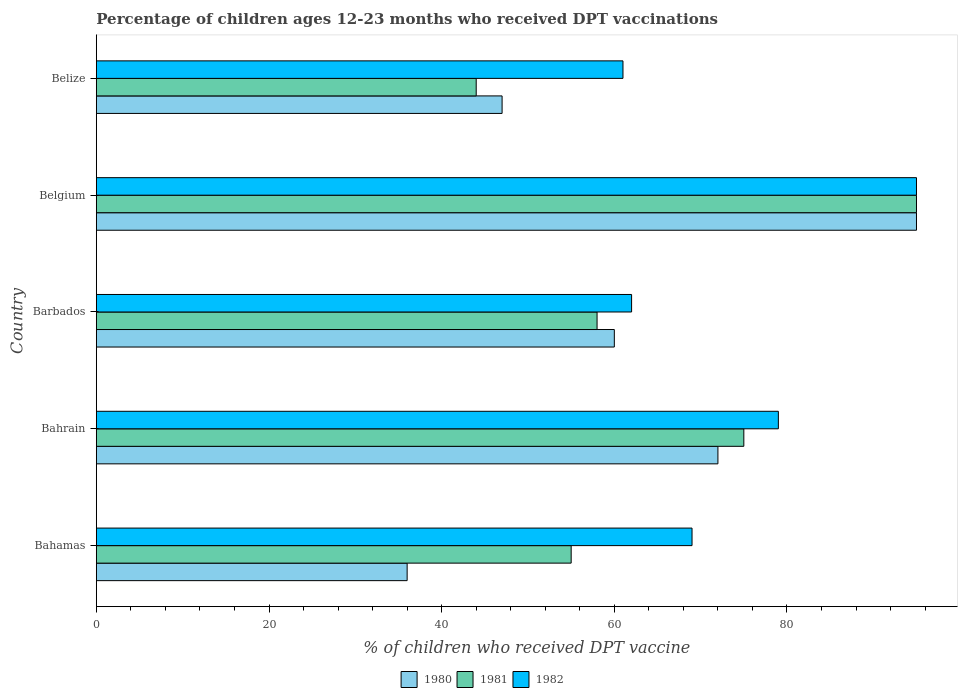How many groups of bars are there?
Offer a very short reply. 5. Are the number of bars on each tick of the Y-axis equal?
Your response must be concise. Yes. How many bars are there on the 1st tick from the bottom?
Ensure brevity in your answer.  3. What is the percentage of children who received DPT vaccination in 1981 in Belize?
Offer a very short reply. 44. Across all countries, what is the maximum percentage of children who received DPT vaccination in 1980?
Provide a succinct answer. 95. In which country was the percentage of children who received DPT vaccination in 1981 minimum?
Your answer should be very brief. Belize. What is the total percentage of children who received DPT vaccination in 1982 in the graph?
Ensure brevity in your answer.  366. What is the difference between the percentage of children who received DPT vaccination in 1982 in Barbados and that in Belgium?
Offer a terse response. -33. What is the difference between the percentage of children who received DPT vaccination in 1980 in Bahrain and the percentage of children who received DPT vaccination in 1981 in Belgium?
Provide a succinct answer. -23. What is the average percentage of children who received DPT vaccination in 1981 per country?
Ensure brevity in your answer.  65.4. What is the difference between the percentage of children who received DPT vaccination in 1980 and percentage of children who received DPT vaccination in 1981 in Bahamas?
Make the answer very short. -19. What is the ratio of the percentage of children who received DPT vaccination in 1981 in Bahrain to that in Belize?
Make the answer very short. 1.7. What is the difference between the highest and the second highest percentage of children who received DPT vaccination in 1981?
Ensure brevity in your answer.  20. What is the difference between the highest and the lowest percentage of children who received DPT vaccination in 1982?
Provide a short and direct response. 34. In how many countries, is the percentage of children who received DPT vaccination in 1980 greater than the average percentage of children who received DPT vaccination in 1980 taken over all countries?
Provide a short and direct response. 2. Is the sum of the percentage of children who received DPT vaccination in 1981 in Bahamas and Belize greater than the maximum percentage of children who received DPT vaccination in 1980 across all countries?
Offer a terse response. Yes. Is it the case that in every country, the sum of the percentage of children who received DPT vaccination in 1980 and percentage of children who received DPT vaccination in 1982 is greater than the percentage of children who received DPT vaccination in 1981?
Keep it short and to the point. Yes. How many bars are there?
Your answer should be compact. 15. Are the values on the major ticks of X-axis written in scientific E-notation?
Provide a succinct answer. No. Does the graph contain grids?
Provide a short and direct response. No. What is the title of the graph?
Ensure brevity in your answer.  Percentage of children ages 12-23 months who received DPT vaccinations. What is the label or title of the X-axis?
Offer a terse response. % of children who received DPT vaccine. What is the label or title of the Y-axis?
Give a very brief answer. Country. What is the % of children who received DPT vaccine of 1980 in Bahamas?
Keep it short and to the point. 36. What is the % of children who received DPT vaccine of 1980 in Bahrain?
Offer a very short reply. 72. What is the % of children who received DPT vaccine of 1981 in Bahrain?
Provide a short and direct response. 75. What is the % of children who received DPT vaccine in 1982 in Bahrain?
Provide a succinct answer. 79. What is the % of children who received DPT vaccine in 1981 in Barbados?
Your answer should be compact. 58. What is the % of children who received DPT vaccine of 1980 in Belgium?
Keep it short and to the point. 95. What is the % of children who received DPT vaccine of 1981 in Belgium?
Give a very brief answer. 95. What is the % of children who received DPT vaccine in 1982 in Belgium?
Ensure brevity in your answer.  95. What is the % of children who received DPT vaccine of 1980 in Belize?
Provide a succinct answer. 47. Across all countries, what is the maximum % of children who received DPT vaccine of 1980?
Make the answer very short. 95. Across all countries, what is the maximum % of children who received DPT vaccine in 1982?
Keep it short and to the point. 95. Across all countries, what is the minimum % of children who received DPT vaccine of 1980?
Your answer should be compact. 36. What is the total % of children who received DPT vaccine of 1980 in the graph?
Keep it short and to the point. 310. What is the total % of children who received DPT vaccine of 1981 in the graph?
Provide a succinct answer. 327. What is the total % of children who received DPT vaccine in 1982 in the graph?
Offer a terse response. 366. What is the difference between the % of children who received DPT vaccine of 1980 in Bahamas and that in Bahrain?
Make the answer very short. -36. What is the difference between the % of children who received DPT vaccine of 1982 in Bahamas and that in Barbados?
Your answer should be very brief. 7. What is the difference between the % of children who received DPT vaccine in 1980 in Bahamas and that in Belgium?
Your answer should be very brief. -59. What is the difference between the % of children who received DPT vaccine of 1981 in Bahamas and that in Belgium?
Make the answer very short. -40. What is the difference between the % of children who received DPT vaccine of 1982 in Bahamas and that in Belgium?
Keep it short and to the point. -26. What is the difference between the % of children who received DPT vaccine in 1980 in Bahamas and that in Belize?
Your response must be concise. -11. What is the difference between the % of children who received DPT vaccine in 1980 in Bahrain and that in Barbados?
Offer a terse response. 12. What is the difference between the % of children who received DPT vaccine of 1981 in Bahrain and that in Barbados?
Offer a terse response. 17. What is the difference between the % of children who received DPT vaccine of 1980 in Bahrain and that in Belgium?
Provide a short and direct response. -23. What is the difference between the % of children who received DPT vaccine of 1981 in Bahrain and that in Belize?
Your answer should be very brief. 31. What is the difference between the % of children who received DPT vaccine of 1982 in Bahrain and that in Belize?
Ensure brevity in your answer.  18. What is the difference between the % of children who received DPT vaccine of 1980 in Barbados and that in Belgium?
Your answer should be compact. -35. What is the difference between the % of children who received DPT vaccine in 1981 in Barbados and that in Belgium?
Your response must be concise. -37. What is the difference between the % of children who received DPT vaccine of 1982 in Barbados and that in Belgium?
Your answer should be compact. -33. What is the difference between the % of children who received DPT vaccine of 1980 in Barbados and that in Belize?
Offer a very short reply. 13. What is the difference between the % of children who received DPT vaccine in 1981 in Barbados and that in Belize?
Give a very brief answer. 14. What is the difference between the % of children who received DPT vaccine in 1982 in Barbados and that in Belize?
Provide a succinct answer. 1. What is the difference between the % of children who received DPT vaccine of 1982 in Belgium and that in Belize?
Your answer should be very brief. 34. What is the difference between the % of children who received DPT vaccine in 1980 in Bahamas and the % of children who received DPT vaccine in 1981 in Bahrain?
Your response must be concise. -39. What is the difference between the % of children who received DPT vaccine of 1980 in Bahamas and the % of children who received DPT vaccine of 1982 in Bahrain?
Ensure brevity in your answer.  -43. What is the difference between the % of children who received DPT vaccine of 1981 in Bahamas and the % of children who received DPT vaccine of 1982 in Bahrain?
Offer a very short reply. -24. What is the difference between the % of children who received DPT vaccine in 1980 in Bahamas and the % of children who received DPT vaccine in 1981 in Barbados?
Offer a terse response. -22. What is the difference between the % of children who received DPT vaccine of 1980 in Bahamas and the % of children who received DPT vaccine of 1982 in Barbados?
Offer a very short reply. -26. What is the difference between the % of children who received DPT vaccine of 1980 in Bahamas and the % of children who received DPT vaccine of 1981 in Belgium?
Provide a succinct answer. -59. What is the difference between the % of children who received DPT vaccine of 1980 in Bahamas and the % of children who received DPT vaccine of 1982 in Belgium?
Make the answer very short. -59. What is the difference between the % of children who received DPT vaccine of 1981 in Bahamas and the % of children who received DPT vaccine of 1982 in Belgium?
Give a very brief answer. -40. What is the difference between the % of children who received DPT vaccine of 1980 in Bahamas and the % of children who received DPT vaccine of 1982 in Belize?
Keep it short and to the point. -25. What is the difference between the % of children who received DPT vaccine in 1980 in Bahrain and the % of children who received DPT vaccine in 1981 in Barbados?
Your response must be concise. 14. What is the difference between the % of children who received DPT vaccine in 1980 in Bahrain and the % of children who received DPT vaccine in 1982 in Barbados?
Your answer should be compact. 10. What is the difference between the % of children who received DPT vaccine in 1980 in Bahrain and the % of children who received DPT vaccine in 1981 in Belgium?
Offer a very short reply. -23. What is the difference between the % of children who received DPT vaccine of 1980 in Bahrain and the % of children who received DPT vaccine of 1981 in Belize?
Provide a succinct answer. 28. What is the difference between the % of children who received DPT vaccine of 1980 in Barbados and the % of children who received DPT vaccine of 1981 in Belgium?
Offer a very short reply. -35. What is the difference between the % of children who received DPT vaccine of 1980 in Barbados and the % of children who received DPT vaccine of 1982 in Belgium?
Your answer should be compact. -35. What is the difference between the % of children who received DPT vaccine of 1981 in Barbados and the % of children who received DPT vaccine of 1982 in Belgium?
Make the answer very short. -37. What is the difference between the % of children who received DPT vaccine in 1981 in Barbados and the % of children who received DPT vaccine in 1982 in Belize?
Your answer should be compact. -3. What is the difference between the % of children who received DPT vaccine in 1980 in Belgium and the % of children who received DPT vaccine in 1981 in Belize?
Make the answer very short. 51. What is the average % of children who received DPT vaccine of 1980 per country?
Ensure brevity in your answer.  62. What is the average % of children who received DPT vaccine in 1981 per country?
Make the answer very short. 65.4. What is the average % of children who received DPT vaccine in 1982 per country?
Your response must be concise. 73.2. What is the difference between the % of children who received DPT vaccine in 1980 and % of children who received DPT vaccine in 1982 in Bahamas?
Provide a succinct answer. -33. What is the difference between the % of children who received DPT vaccine of 1981 and % of children who received DPT vaccine of 1982 in Bahamas?
Ensure brevity in your answer.  -14. What is the difference between the % of children who received DPT vaccine in 1981 and % of children who received DPT vaccine in 1982 in Bahrain?
Offer a very short reply. -4. What is the difference between the % of children who received DPT vaccine in 1980 and % of children who received DPT vaccine in 1981 in Barbados?
Your answer should be very brief. 2. What is the difference between the % of children who received DPT vaccine in 1981 and % of children who received DPT vaccine in 1982 in Barbados?
Ensure brevity in your answer.  -4. What is the difference between the % of children who received DPT vaccine of 1981 and % of children who received DPT vaccine of 1982 in Belgium?
Ensure brevity in your answer.  0. What is the ratio of the % of children who received DPT vaccine in 1980 in Bahamas to that in Bahrain?
Make the answer very short. 0.5. What is the ratio of the % of children who received DPT vaccine in 1981 in Bahamas to that in Bahrain?
Ensure brevity in your answer.  0.73. What is the ratio of the % of children who received DPT vaccine in 1982 in Bahamas to that in Bahrain?
Give a very brief answer. 0.87. What is the ratio of the % of children who received DPT vaccine of 1980 in Bahamas to that in Barbados?
Your answer should be compact. 0.6. What is the ratio of the % of children who received DPT vaccine of 1981 in Bahamas to that in Barbados?
Your response must be concise. 0.95. What is the ratio of the % of children who received DPT vaccine of 1982 in Bahamas to that in Barbados?
Offer a terse response. 1.11. What is the ratio of the % of children who received DPT vaccine in 1980 in Bahamas to that in Belgium?
Your answer should be compact. 0.38. What is the ratio of the % of children who received DPT vaccine in 1981 in Bahamas to that in Belgium?
Your answer should be compact. 0.58. What is the ratio of the % of children who received DPT vaccine in 1982 in Bahamas to that in Belgium?
Make the answer very short. 0.73. What is the ratio of the % of children who received DPT vaccine of 1980 in Bahamas to that in Belize?
Provide a short and direct response. 0.77. What is the ratio of the % of children who received DPT vaccine in 1981 in Bahamas to that in Belize?
Provide a succinct answer. 1.25. What is the ratio of the % of children who received DPT vaccine in 1982 in Bahamas to that in Belize?
Offer a terse response. 1.13. What is the ratio of the % of children who received DPT vaccine of 1981 in Bahrain to that in Barbados?
Offer a very short reply. 1.29. What is the ratio of the % of children who received DPT vaccine of 1982 in Bahrain to that in Barbados?
Ensure brevity in your answer.  1.27. What is the ratio of the % of children who received DPT vaccine in 1980 in Bahrain to that in Belgium?
Your response must be concise. 0.76. What is the ratio of the % of children who received DPT vaccine of 1981 in Bahrain to that in Belgium?
Ensure brevity in your answer.  0.79. What is the ratio of the % of children who received DPT vaccine in 1982 in Bahrain to that in Belgium?
Provide a short and direct response. 0.83. What is the ratio of the % of children who received DPT vaccine in 1980 in Bahrain to that in Belize?
Provide a short and direct response. 1.53. What is the ratio of the % of children who received DPT vaccine of 1981 in Bahrain to that in Belize?
Your answer should be very brief. 1.7. What is the ratio of the % of children who received DPT vaccine of 1982 in Bahrain to that in Belize?
Provide a succinct answer. 1.3. What is the ratio of the % of children who received DPT vaccine in 1980 in Barbados to that in Belgium?
Provide a short and direct response. 0.63. What is the ratio of the % of children who received DPT vaccine of 1981 in Barbados to that in Belgium?
Provide a short and direct response. 0.61. What is the ratio of the % of children who received DPT vaccine in 1982 in Barbados to that in Belgium?
Your response must be concise. 0.65. What is the ratio of the % of children who received DPT vaccine of 1980 in Barbados to that in Belize?
Offer a terse response. 1.28. What is the ratio of the % of children who received DPT vaccine of 1981 in Barbados to that in Belize?
Ensure brevity in your answer.  1.32. What is the ratio of the % of children who received DPT vaccine in 1982 in Barbados to that in Belize?
Your answer should be compact. 1.02. What is the ratio of the % of children who received DPT vaccine in 1980 in Belgium to that in Belize?
Your response must be concise. 2.02. What is the ratio of the % of children who received DPT vaccine in 1981 in Belgium to that in Belize?
Your answer should be compact. 2.16. What is the ratio of the % of children who received DPT vaccine of 1982 in Belgium to that in Belize?
Provide a short and direct response. 1.56. What is the difference between the highest and the second highest % of children who received DPT vaccine in 1980?
Your answer should be very brief. 23. What is the difference between the highest and the second highest % of children who received DPT vaccine of 1982?
Your response must be concise. 16. What is the difference between the highest and the lowest % of children who received DPT vaccine in 1982?
Offer a very short reply. 34. 